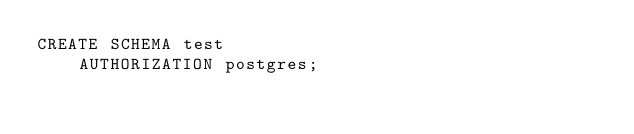<code> <loc_0><loc_0><loc_500><loc_500><_SQL_>CREATE SCHEMA test
    AUTHORIZATION postgres;</code> 